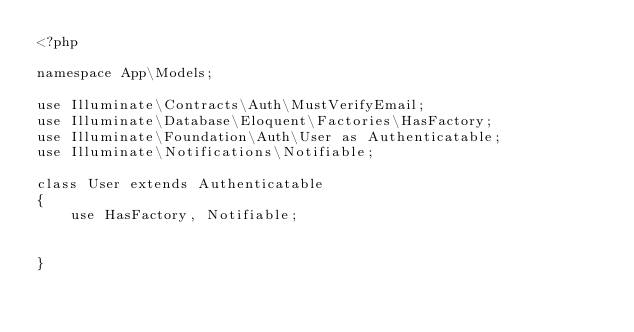Convert code to text. <code><loc_0><loc_0><loc_500><loc_500><_PHP_><?php

namespace App\Models;

use Illuminate\Contracts\Auth\MustVerifyEmail;
use Illuminate\Database\Eloquent\Factories\HasFactory;
use Illuminate\Foundation\Auth\User as Authenticatable;
use Illuminate\Notifications\Notifiable;

class User extends Authenticatable
{
    use HasFactory, Notifiable;
  

}
  </code> 